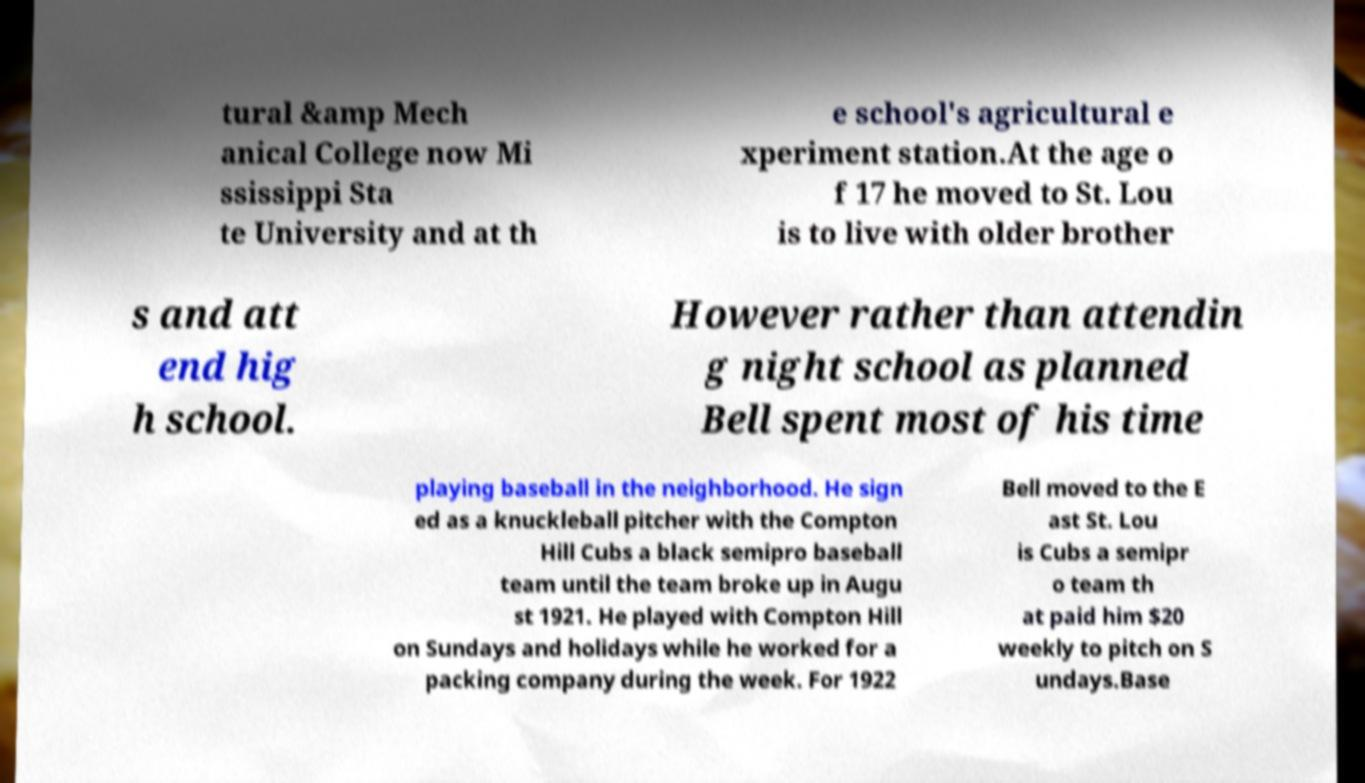Can you read and provide the text displayed in the image?This photo seems to have some interesting text. Can you extract and type it out for me? tural &amp Mech anical College now Mi ssissippi Sta te University and at th e school's agricultural e xperiment station.At the age o f 17 he moved to St. Lou is to live with older brother s and att end hig h school. However rather than attendin g night school as planned Bell spent most of his time playing baseball in the neighborhood. He sign ed as a knuckleball pitcher with the Compton Hill Cubs a black semipro baseball team until the team broke up in Augu st 1921. He played with Compton Hill on Sundays and holidays while he worked for a packing company during the week. For 1922 Bell moved to the E ast St. Lou is Cubs a semipr o team th at paid him $20 weekly to pitch on S undays.Base 